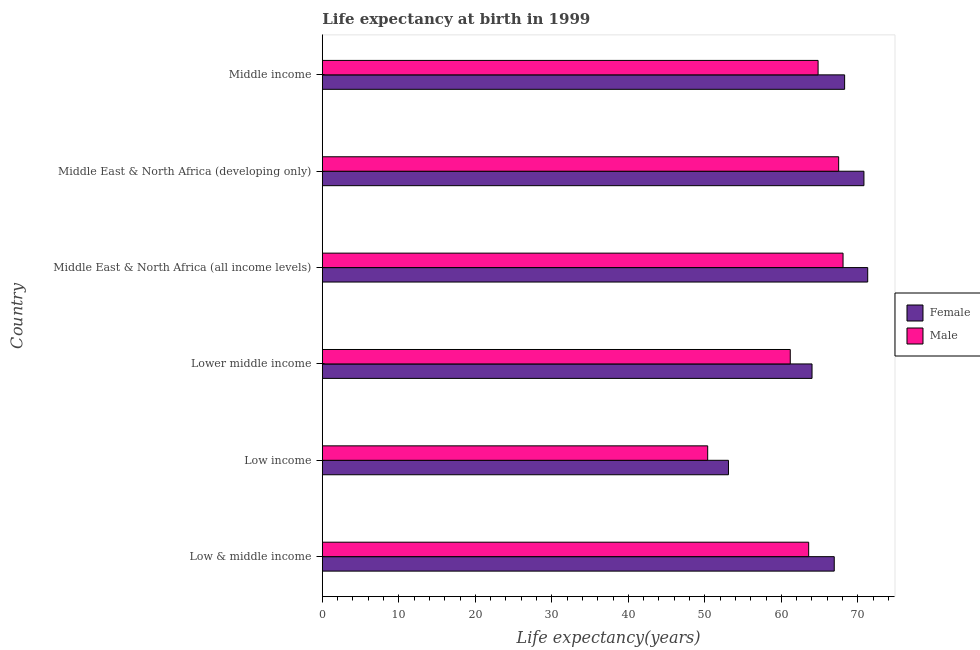How many groups of bars are there?
Offer a terse response. 6. Are the number of bars on each tick of the Y-axis equal?
Provide a short and direct response. Yes. How many bars are there on the 6th tick from the top?
Offer a very short reply. 2. What is the label of the 3rd group of bars from the top?
Provide a succinct answer. Middle East & North Africa (all income levels). In how many cases, is the number of bars for a given country not equal to the number of legend labels?
Your answer should be very brief. 0. What is the life expectancy(female) in Middle East & North Africa (all income levels)?
Make the answer very short. 71.28. Across all countries, what is the maximum life expectancy(male)?
Keep it short and to the point. 68.06. Across all countries, what is the minimum life expectancy(female)?
Your answer should be very brief. 53.08. In which country was the life expectancy(male) maximum?
Keep it short and to the point. Middle East & North Africa (all income levels). What is the total life expectancy(male) in the graph?
Make the answer very short. 375.45. What is the difference between the life expectancy(male) in Low & middle income and that in Middle East & North Africa (all income levels)?
Provide a succinct answer. -4.49. What is the difference between the life expectancy(male) in Low & middle income and the life expectancy(female) in Low income?
Make the answer very short. 10.48. What is the average life expectancy(female) per country?
Provide a succinct answer. 65.72. What is the difference between the life expectancy(female) and life expectancy(male) in Low income?
Offer a terse response. 2.72. In how many countries, is the life expectancy(male) greater than 62 years?
Provide a succinct answer. 4. What is the ratio of the life expectancy(male) in Low & middle income to that in Middle East & North Africa (all income levels)?
Make the answer very short. 0.93. Is the difference between the life expectancy(female) in Low & middle income and Middle East & North Africa (all income levels) greater than the difference between the life expectancy(male) in Low & middle income and Middle East & North Africa (all income levels)?
Your answer should be compact. Yes. What is the difference between the highest and the second highest life expectancy(male)?
Offer a very short reply. 0.57. What is the difference between the highest and the lowest life expectancy(female)?
Your response must be concise. 18.2. In how many countries, is the life expectancy(male) greater than the average life expectancy(male) taken over all countries?
Offer a terse response. 4. What does the 1st bar from the bottom in Low & middle income represents?
Ensure brevity in your answer.  Female. Are all the bars in the graph horizontal?
Your response must be concise. Yes. How many countries are there in the graph?
Keep it short and to the point. 6. What is the difference between two consecutive major ticks on the X-axis?
Offer a terse response. 10. Does the graph contain any zero values?
Give a very brief answer. No. Does the graph contain grids?
Offer a terse response. No. What is the title of the graph?
Keep it short and to the point. Life expectancy at birth in 1999. Does "Broad money growth" appear as one of the legend labels in the graph?
Ensure brevity in your answer.  No. What is the label or title of the X-axis?
Keep it short and to the point. Life expectancy(years). What is the Life expectancy(years) of Female in Low & middle income?
Your response must be concise. 66.91. What is the Life expectancy(years) of Male in Low & middle income?
Offer a very short reply. 63.57. What is the Life expectancy(years) in Female in Low income?
Make the answer very short. 53.08. What is the Life expectancy(years) of Male in Low income?
Keep it short and to the point. 50.37. What is the Life expectancy(years) in Female in Lower middle income?
Provide a succinct answer. 64.01. What is the Life expectancy(years) of Male in Lower middle income?
Give a very brief answer. 61.16. What is the Life expectancy(years) of Female in Middle East & North Africa (all income levels)?
Your answer should be very brief. 71.28. What is the Life expectancy(years) in Male in Middle East & North Africa (all income levels)?
Offer a terse response. 68.06. What is the Life expectancy(years) of Female in Middle East & North Africa (developing only)?
Your answer should be very brief. 70.79. What is the Life expectancy(years) of Male in Middle East & North Africa (developing only)?
Your answer should be very brief. 67.49. What is the Life expectancy(years) of Female in Middle income?
Keep it short and to the point. 68.27. What is the Life expectancy(years) of Male in Middle income?
Provide a short and direct response. 64.8. Across all countries, what is the maximum Life expectancy(years) in Female?
Your answer should be compact. 71.28. Across all countries, what is the maximum Life expectancy(years) of Male?
Provide a succinct answer. 68.06. Across all countries, what is the minimum Life expectancy(years) in Female?
Offer a terse response. 53.08. Across all countries, what is the minimum Life expectancy(years) of Male?
Offer a terse response. 50.37. What is the total Life expectancy(years) of Female in the graph?
Your response must be concise. 394.34. What is the total Life expectancy(years) in Male in the graph?
Offer a very short reply. 375.45. What is the difference between the Life expectancy(years) in Female in Low & middle income and that in Low income?
Offer a terse response. 13.83. What is the difference between the Life expectancy(years) of Male in Low & middle income and that in Low income?
Provide a short and direct response. 13.2. What is the difference between the Life expectancy(years) in Female in Low & middle income and that in Lower middle income?
Give a very brief answer. 2.9. What is the difference between the Life expectancy(years) of Male in Low & middle income and that in Lower middle income?
Offer a terse response. 2.4. What is the difference between the Life expectancy(years) of Female in Low & middle income and that in Middle East & North Africa (all income levels)?
Provide a succinct answer. -4.37. What is the difference between the Life expectancy(years) in Male in Low & middle income and that in Middle East & North Africa (all income levels)?
Give a very brief answer. -4.49. What is the difference between the Life expectancy(years) in Female in Low & middle income and that in Middle East & North Africa (developing only)?
Your answer should be very brief. -3.88. What is the difference between the Life expectancy(years) in Male in Low & middle income and that in Middle East & North Africa (developing only)?
Keep it short and to the point. -3.92. What is the difference between the Life expectancy(years) of Female in Low & middle income and that in Middle income?
Your answer should be compact. -1.36. What is the difference between the Life expectancy(years) of Male in Low & middle income and that in Middle income?
Provide a short and direct response. -1.23. What is the difference between the Life expectancy(years) in Female in Low income and that in Lower middle income?
Provide a succinct answer. -10.92. What is the difference between the Life expectancy(years) of Male in Low income and that in Lower middle income?
Give a very brief answer. -10.79. What is the difference between the Life expectancy(years) of Female in Low income and that in Middle East & North Africa (all income levels)?
Give a very brief answer. -18.2. What is the difference between the Life expectancy(years) of Male in Low income and that in Middle East & North Africa (all income levels)?
Your answer should be compact. -17.69. What is the difference between the Life expectancy(years) of Female in Low income and that in Middle East & North Africa (developing only)?
Provide a succinct answer. -17.71. What is the difference between the Life expectancy(years) of Male in Low income and that in Middle East & North Africa (developing only)?
Offer a very short reply. -17.12. What is the difference between the Life expectancy(years) in Female in Low income and that in Middle income?
Ensure brevity in your answer.  -15.18. What is the difference between the Life expectancy(years) of Male in Low income and that in Middle income?
Give a very brief answer. -14.43. What is the difference between the Life expectancy(years) in Female in Lower middle income and that in Middle East & North Africa (all income levels)?
Your answer should be very brief. -7.28. What is the difference between the Life expectancy(years) of Male in Lower middle income and that in Middle East & North Africa (all income levels)?
Give a very brief answer. -6.9. What is the difference between the Life expectancy(years) in Female in Lower middle income and that in Middle East & North Africa (developing only)?
Your answer should be compact. -6.78. What is the difference between the Life expectancy(years) in Male in Lower middle income and that in Middle East & North Africa (developing only)?
Provide a succinct answer. -6.32. What is the difference between the Life expectancy(years) of Female in Lower middle income and that in Middle income?
Provide a succinct answer. -4.26. What is the difference between the Life expectancy(years) of Male in Lower middle income and that in Middle income?
Provide a succinct answer. -3.64. What is the difference between the Life expectancy(years) of Female in Middle East & North Africa (all income levels) and that in Middle East & North Africa (developing only)?
Give a very brief answer. 0.49. What is the difference between the Life expectancy(years) in Male in Middle East & North Africa (all income levels) and that in Middle East & North Africa (developing only)?
Ensure brevity in your answer.  0.57. What is the difference between the Life expectancy(years) in Female in Middle East & North Africa (all income levels) and that in Middle income?
Your response must be concise. 3.02. What is the difference between the Life expectancy(years) of Male in Middle East & North Africa (all income levels) and that in Middle income?
Provide a succinct answer. 3.26. What is the difference between the Life expectancy(years) of Female in Middle East & North Africa (developing only) and that in Middle income?
Your answer should be very brief. 2.52. What is the difference between the Life expectancy(years) in Male in Middle East & North Africa (developing only) and that in Middle income?
Your answer should be compact. 2.69. What is the difference between the Life expectancy(years) in Female in Low & middle income and the Life expectancy(years) in Male in Low income?
Make the answer very short. 16.54. What is the difference between the Life expectancy(years) of Female in Low & middle income and the Life expectancy(years) of Male in Lower middle income?
Keep it short and to the point. 5.75. What is the difference between the Life expectancy(years) of Female in Low & middle income and the Life expectancy(years) of Male in Middle East & North Africa (all income levels)?
Provide a succinct answer. -1.15. What is the difference between the Life expectancy(years) of Female in Low & middle income and the Life expectancy(years) of Male in Middle East & North Africa (developing only)?
Give a very brief answer. -0.58. What is the difference between the Life expectancy(years) of Female in Low & middle income and the Life expectancy(years) of Male in Middle income?
Offer a very short reply. 2.11. What is the difference between the Life expectancy(years) in Female in Low income and the Life expectancy(years) in Male in Lower middle income?
Give a very brief answer. -8.08. What is the difference between the Life expectancy(years) in Female in Low income and the Life expectancy(years) in Male in Middle East & North Africa (all income levels)?
Give a very brief answer. -14.98. What is the difference between the Life expectancy(years) of Female in Low income and the Life expectancy(years) of Male in Middle East & North Africa (developing only)?
Your answer should be compact. -14.4. What is the difference between the Life expectancy(years) of Female in Low income and the Life expectancy(years) of Male in Middle income?
Your answer should be very brief. -11.72. What is the difference between the Life expectancy(years) in Female in Lower middle income and the Life expectancy(years) in Male in Middle East & North Africa (all income levels)?
Offer a very short reply. -4.05. What is the difference between the Life expectancy(years) of Female in Lower middle income and the Life expectancy(years) of Male in Middle East & North Africa (developing only)?
Provide a short and direct response. -3.48. What is the difference between the Life expectancy(years) in Female in Lower middle income and the Life expectancy(years) in Male in Middle income?
Keep it short and to the point. -0.79. What is the difference between the Life expectancy(years) of Female in Middle East & North Africa (all income levels) and the Life expectancy(years) of Male in Middle East & North Africa (developing only)?
Provide a succinct answer. 3.8. What is the difference between the Life expectancy(years) of Female in Middle East & North Africa (all income levels) and the Life expectancy(years) of Male in Middle income?
Make the answer very short. 6.49. What is the difference between the Life expectancy(years) in Female in Middle East & North Africa (developing only) and the Life expectancy(years) in Male in Middle income?
Make the answer very short. 5.99. What is the average Life expectancy(years) in Female per country?
Provide a short and direct response. 65.72. What is the average Life expectancy(years) of Male per country?
Your response must be concise. 62.57. What is the difference between the Life expectancy(years) in Female and Life expectancy(years) in Male in Low & middle income?
Your answer should be very brief. 3.34. What is the difference between the Life expectancy(years) in Female and Life expectancy(years) in Male in Low income?
Provide a short and direct response. 2.72. What is the difference between the Life expectancy(years) in Female and Life expectancy(years) in Male in Lower middle income?
Your answer should be very brief. 2.84. What is the difference between the Life expectancy(years) of Female and Life expectancy(years) of Male in Middle East & North Africa (all income levels)?
Your answer should be compact. 3.22. What is the difference between the Life expectancy(years) in Female and Life expectancy(years) in Male in Middle East & North Africa (developing only)?
Your answer should be very brief. 3.3. What is the difference between the Life expectancy(years) of Female and Life expectancy(years) of Male in Middle income?
Your response must be concise. 3.47. What is the ratio of the Life expectancy(years) of Female in Low & middle income to that in Low income?
Keep it short and to the point. 1.26. What is the ratio of the Life expectancy(years) in Male in Low & middle income to that in Low income?
Keep it short and to the point. 1.26. What is the ratio of the Life expectancy(years) in Female in Low & middle income to that in Lower middle income?
Give a very brief answer. 1.05. What is the ratio of the Life expectancy(years) of Male in Low & middle income to that in Lower middle income?
Make the answer very short. 1.04. What is the ratio of the Life expectancy(years) of Female in Low & middle income to that in Middle East & North Africa (all income levels)?
Provide a short and direct response. 0.94. What is the ratio of the Life expectancy(years) in Male in Low & middle income to that in Middle East & North Africa (all income levels)?
Keep it short and to the point. 0.93. What is the ratio of the Life expectancy(years) of Female in Low & middle income to that in Middle East & North Africa (developing only)?
Offer a terse response. 0.95. What is the ratio of the Life expectancy(years) in Male in Low & middle income to that in Middle East & North Africa (developing only)?
Provide a short and direct response. 0.94. What is the ratio of the Life expectancy(years) of Female in Low & middle income to that in Middle income?
Keep it short and to the point. 0.98. What is the ratio of the Life expectancy(years) of Male in Low & middle income to that in Middle income?
Ensure brevity in your answer.  0.98. What is the ratio of the Life expectancy(years) in Female in Low income to that in Lower middle income?
Provide a short and direct response. 0.83. What is the ratio of the Life expectancy(years) in Male in Low income to that in Lower middle income?
Keep it short and to the point. 0.82. What is the ratio of the Life expectancy(years) in Female in Low income to that in Middle East & North Africa (all income levels)?
Provide a short and direct response. 0.74. What is the ratio of the Life expectancy(years) in Male in Low income to that in Middle East & North Africa (all income levels)?
Provide a short and direct response. 0.74. What is the ratio of the Life expectancy(years) of Female in Low income to that in Middle East & North Africa (developing only)?
Offer a very short reply. 0.75. What is the ratio of the Life expectancy(years) of Male in Low income to that in Middle East & North Africa (developing only)?
Your answer should be very brief. 0.75. What is the ratio of the Life expectancy(years) of Female in Low income to that in Middle income?
Ensure brevity in your answer.  0.78. What is the ratio of the Life expectancy(years) of Male in Low income to that in Middle income?
Provide a succinct answer. 0.78. What is the ratio of the Life expectancy(years) of Female in Lower middle income to that in Middle East & North Africa (all income levels)?
Your response must be concise. 0.9. What is the ratio of the Life expectancy(years) of Male in Lower middle income to that in Middle East & North Africa (all income levels)?
Provide a succinct answer. 0.9. What is the ratio of the Life expectancy(years) in Female in Lower middle income to that in Middle East & North Africa (developing only)?
Offer a terse response. 0.9. What is the ratio of the Life expectancy(years) in Male in Lower middle income to that in Middle East & North Africa (developing only)?
Keep it short and to the point. 0.91. What is the ratio of the Life expectancy(years) of Female in Lower middle income to that in Middle income?
Your response must be concise. 0.94. What is the ratio of the Life expectancy(years) of Male in Lower middle income to that in Middle income?
Ensure brevity in your answer.  0.94. What is the ratio of the Life expectancy(years) in Male in Middle East & North Africa (all income levels) to that in Middle East & North Africa (developing only)?
Ensure brevity in your answer.  1.01. What is the ratio of the Life expectancy(years) of Female in Middle East & North Africa (all income levels) to that in Middle income?
Offer a very short reply. 1.04. What is the ratio of the Life expectancy(years) in Male in Middle East & North Africa (all income levels) to that in Middle income?
Provide a succinct answer. 1.05. What is the ratio of the Life expectancy(years) of Male in Middle East & North Africa (developing only) to that in Middle income?
Ensure brevity in your answer.  1.04. What is the difference between the highest and the second highest Life expectancy(years) in Female?
Provide a succinct answer. 0.49. What is the difference between the highest and the second highest Life expectancy(years) in Male?
Keep it short and to the point. 0.57. What is the difference between the highest and the lowest Life expectancy(years) in Female?
Make the answer very short. 18.2. What is the difference between the highest and the lowest Life expectancy(years) of Male?
Your response must be concise. 17.69. 